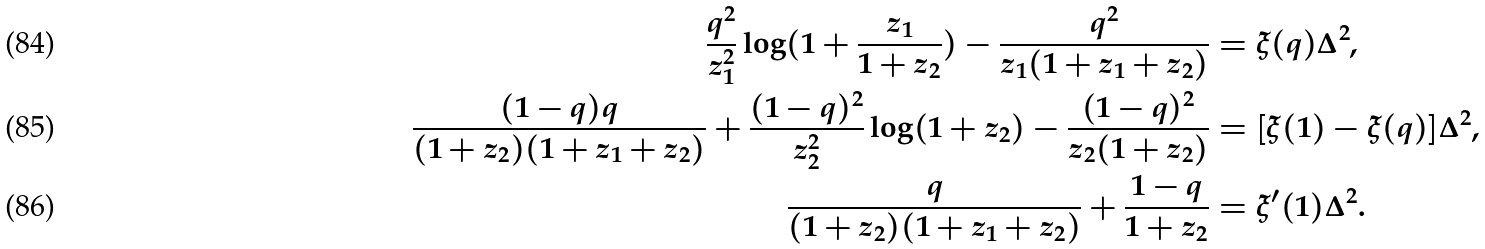<formula> <loc_0><loc_0><loc_500><loc_500>\frac { q ^ { 2 } } { z _ { 1 } ^ { 2 } } \log ( 1 + \frac { z _ { 1 } } { 1 + z _ { 2 } } ) - \frac { q ^ { 2 } } { z _ { 1 } ( 1 + z _ { 1 } + z _ { 2 } ) } & = \xi ( q ) \Delta ^ { 2 } , \\ \frac { ( 1 - q ) q } { ( 1 + z _ { 2 } ) ( 1 + z _ { 1 } + z _ { 2 } ) } + \frac { ( 1 - q ) ^ { 2 } } { z _ { 2 } ^ { 2 } } \log ( 1 + z _ { 2 } ) - \frac { ( 1 - q ) ^ { 2 } } { z _ { 2 } ( 1 + z _ { 2 } ) } & = [ \xi ( 1 ) - \xi ( q ) ] \Delta ^ { 2 } , \\ \frac { q } { ( 1 + z _ { 2 } ) ( 1 + z _ { 1 } + z _ { 2 } ) } + \frac { 1 - q } { 1 + z _ { 2 } } & = \xi ^ { \prime } ( 1 ) \Delta ^ { 2 } .</formula> 